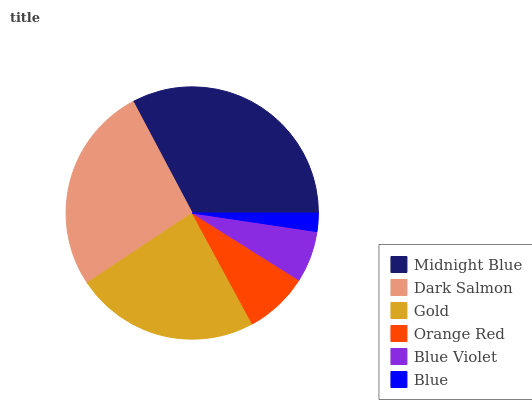Is Blue the minimum?
Answer yes or no. Yes. Is Midnight Blue the maximum?
Answer yes or no. Yes. Is Dark Salmon the minimum?
Answer yes or no. No. Is Dark Salmon the maximum?
Answer yes or no. No. Is Midnight Blue greater than Dark Salmon?
Answer yes or no. Yes. Is Dark Salmon less than Midnight Blue?
Answer yes or no. Yes. Is Dark Salmon greater than Midnight Blue?
Answer yes or no. No. Is Midnight Blue less than Dark Salmon?
Answer yes or no. No. Is Gold the high median?
Answer yes or no. Yes. Is Orange Red the low median?
Answer yes or no. Yes. Is Midnight Blue the high median?
Answer yes or no. No. Is Gold the low median?
Answer yes or no. No. 